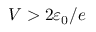Convert formula to latex. <formula><loc_0><loc_0><loc_500><loc_500>V > 2 \varepsilon _ { 0 } / e</formula> 